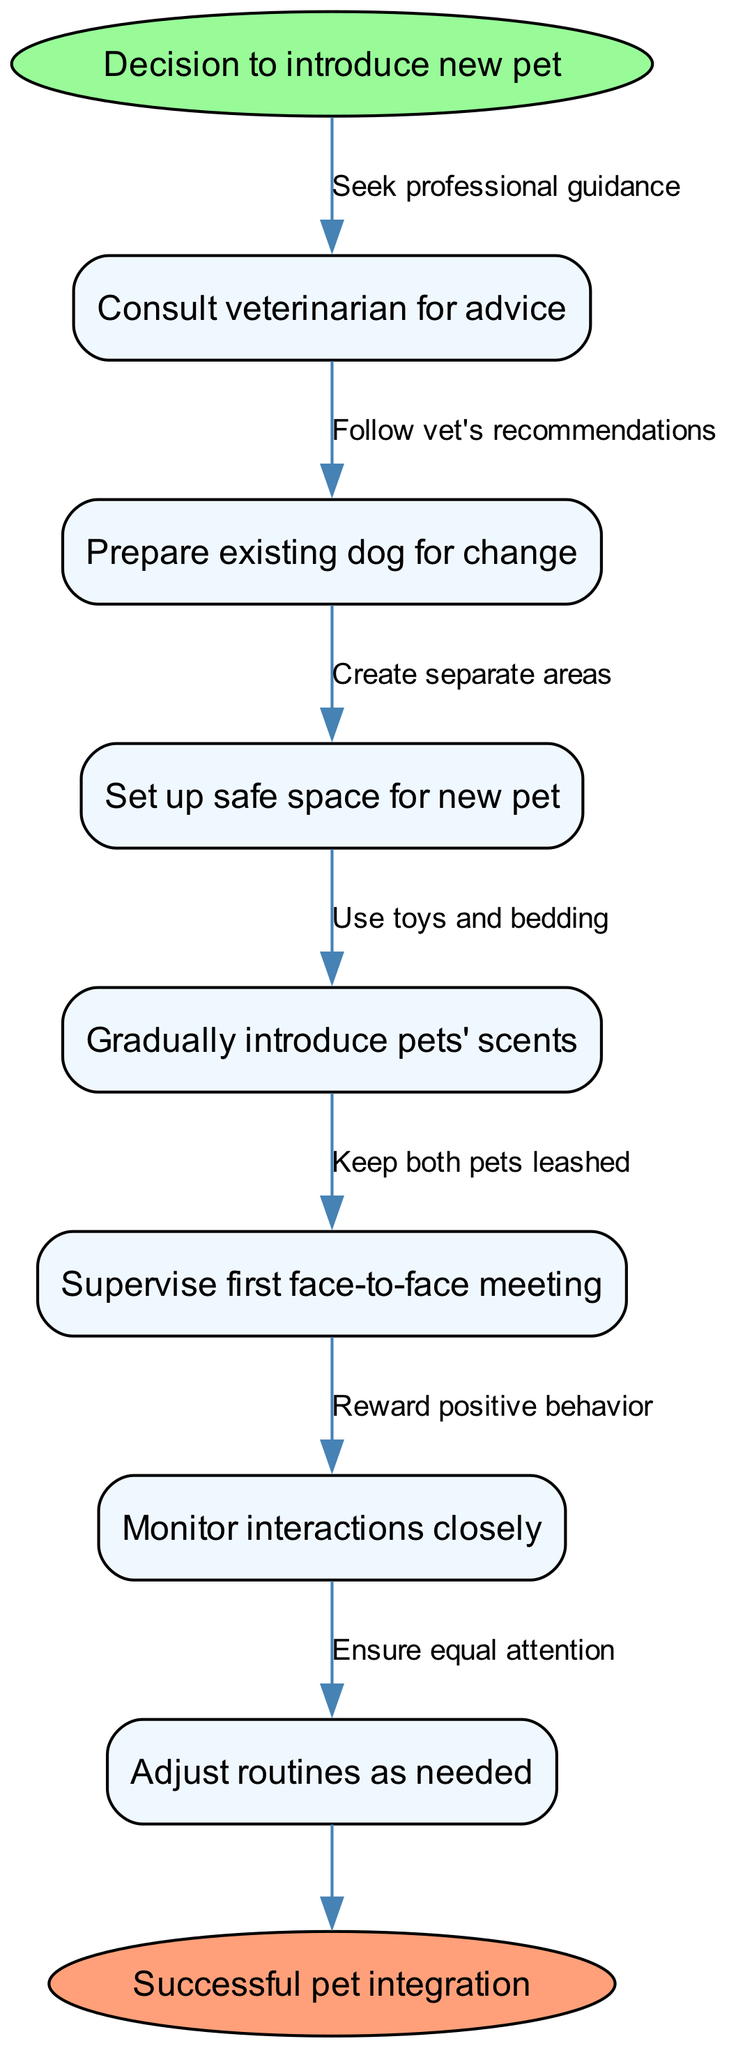What is the starting point of the procedure? The starting point is indicated by the 'start' node which states "Decision to introduce new pet." This is the first point in the flowchart from which all subsequent actions are derived.
Answer: Decision to introduce new pet How many nodes are present in the diagram? To find this, count all the nodes listed. There are seven nodes that represent different steps in the procedure for introducing a new pet.
Answer: 7 What is the last step before the successful pet integration? The last step before reaching the end node, "Successful pet integration", is the node "Adjust routines as needed", which indicates the final preparatory action before integration is considered complete.
Answer: Adjust routines as needed What edge connects the first and second nodes? The edge between the first node "Consult veterinarian for advice" and the second node "Prepare existing dog for change" is labeled "Seek professional guidance," which signifies the advice of a professional as the transition between these two actions.
Answer: Seek professional guidance What is the action associated with monitoring interactions closely? This action, "Monitor interactions closely," is associated with the positive reinforcement of behavior that develops in interactions between the existing dog and the new pet, corresponding to the edge "Reward positive behavior."
Answer: Reward positive behavior Which node indicates the preparation of a safe area for the new pet? The node that suggests creating a safe environment is labeled "Set up safe space for new pet," indicating the need to prepare a secure area before the new pet's arrival.
Answer: Set up safe space for new pet Which nodes involve interactions between pets? The nodes that detail the interactions between the pets are "Gradually introduce pets' scents," "Supervise first face-to-face meeting," and "Monitor interactions closely," as these all relate to the process of acclimating the pets to one another.
Answer: Gradually introduce pets' scents, Supervise first face-to-face meeting, Monitor interactions closely 